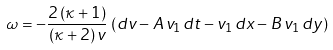<formula> <loc_0><loc_0><loc_500><loc_500>\omega = - \frac { 2 \, ( \kappa + 1 ) } { ( \kappa + 2 ) \, v } \, \left ( d v - A \, v _ { 1 } \, d t - v _ { 1 } \, d x - B \, v _ { 1 } \, d y \right )</formula> 